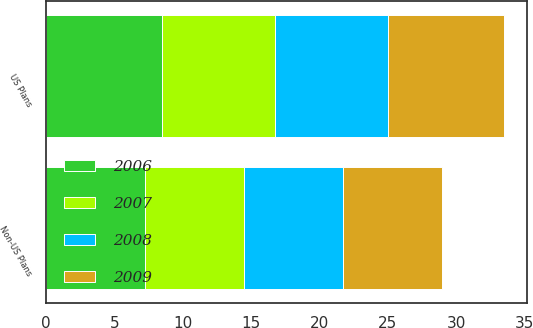Convert chart. <chart><loc_0><loc_0><loc_500><loc_500><stacked_bar_chart><ecel><fcel>US Plans<fcel>Non-US Plans<nl><fcel>2007<fcel>8.25<fcel>7.25<nl><fcel>2008<fcel>8.25<fcel>7.25<nl><fcel>2006<fcel>8.5<fcel>7.24<nl><fcel>2009<fcel>8.5<fcel>7.24<nl></chart> 